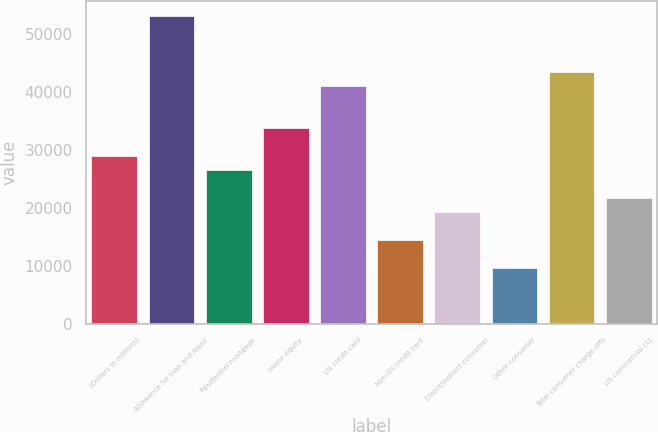Convert chart to OTSL. <chart><loc_0><loc_0><loc_500><loc_500><bar_chart><fcel>(Dollars in millions)<fcel>Allowance for loan and lease<fcel>Residential mortgage<fcel>Home equity<fcel>US credit card<fcel>Non-US credit card<fcel>Direct/Indirect consumer<fcel>Other consumer<fcel>Total consumer charge-offs<fcel>US commercial (1)<nl><fcel>29014<fcel>53189<fcel>26596.5<fcel>33849<fcel>41101.5<fcel>14509<fcel>19344<fcel>9674<fcel>43519<fcel>21761.5<nl></chart> 